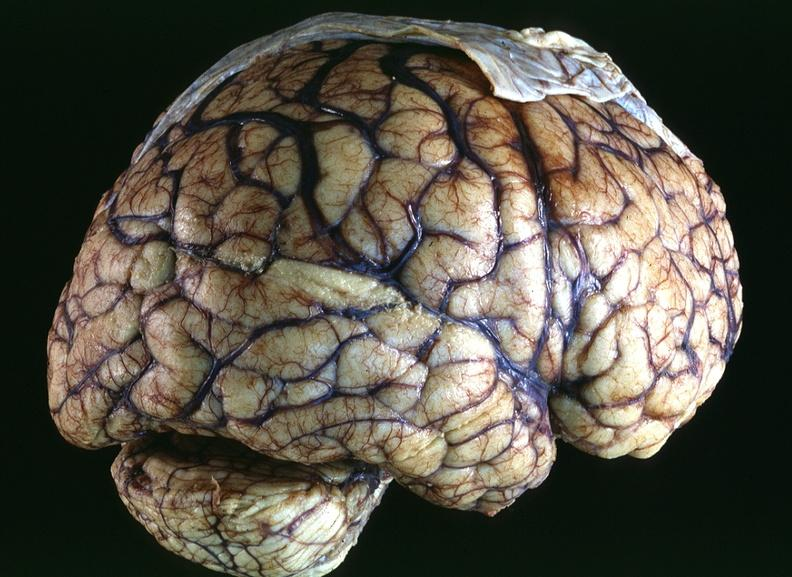s nervous present?
Answer the question using a single word or phrase. Yes 